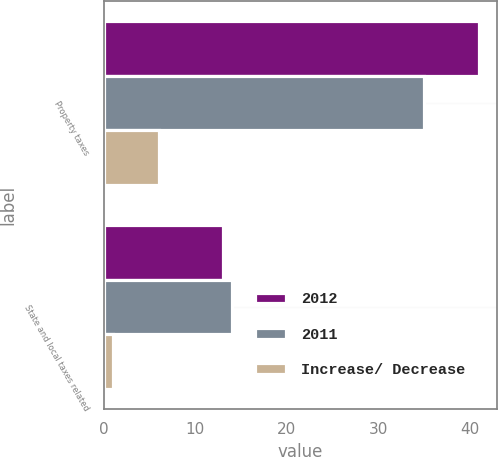<chart> <loc_0><loc_0><loc_500><loc_500><stacked_bar_chart><ecel><fcel>Property taxes<fcel>State and local taxes related<nl><fcel>2012<fcel>41<fcel>13<nl><fcel>2011<fcel>35<fcel>14<nl><fcel>Increase/ Decrease<fcel>6<fcel>1<nl></chart> 